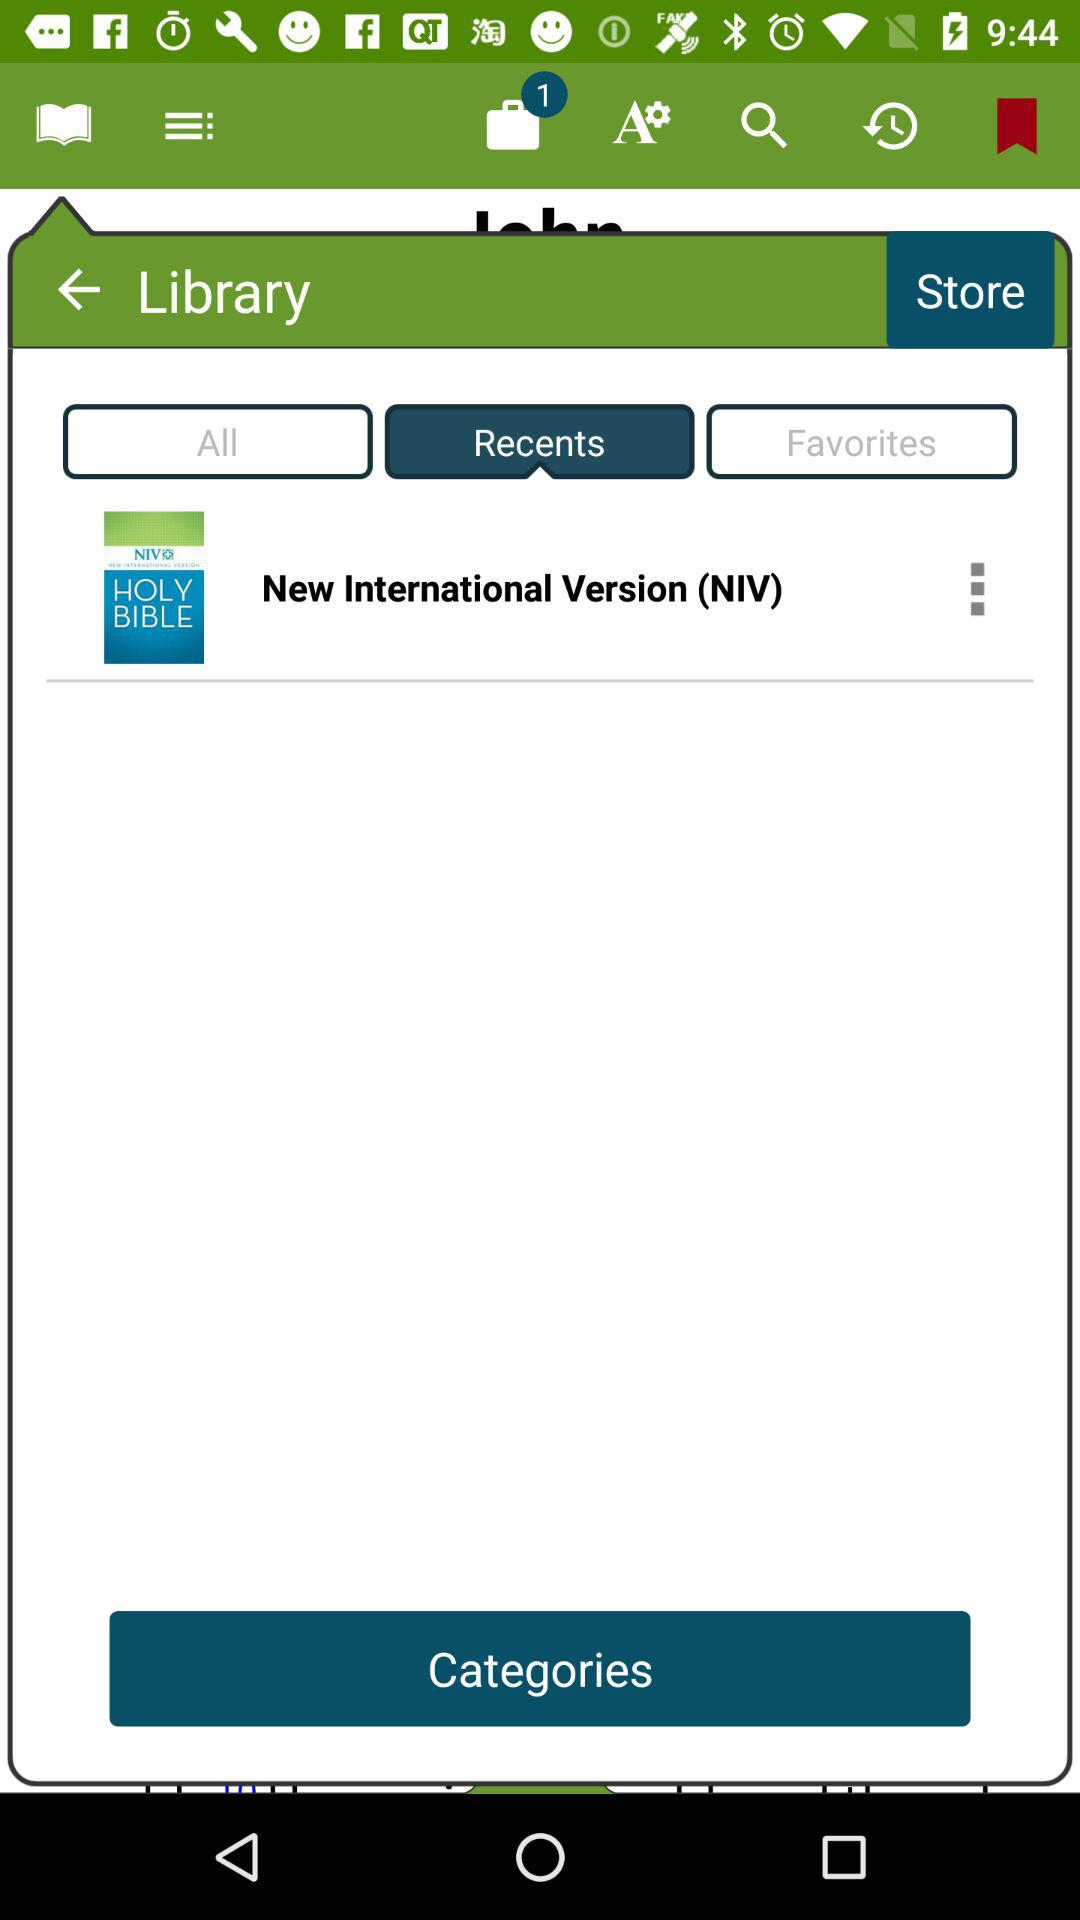What is the version of the "HOLY BIBLE"? The version of the "HOLY BIBLE" is "New International Version (NIV)". 